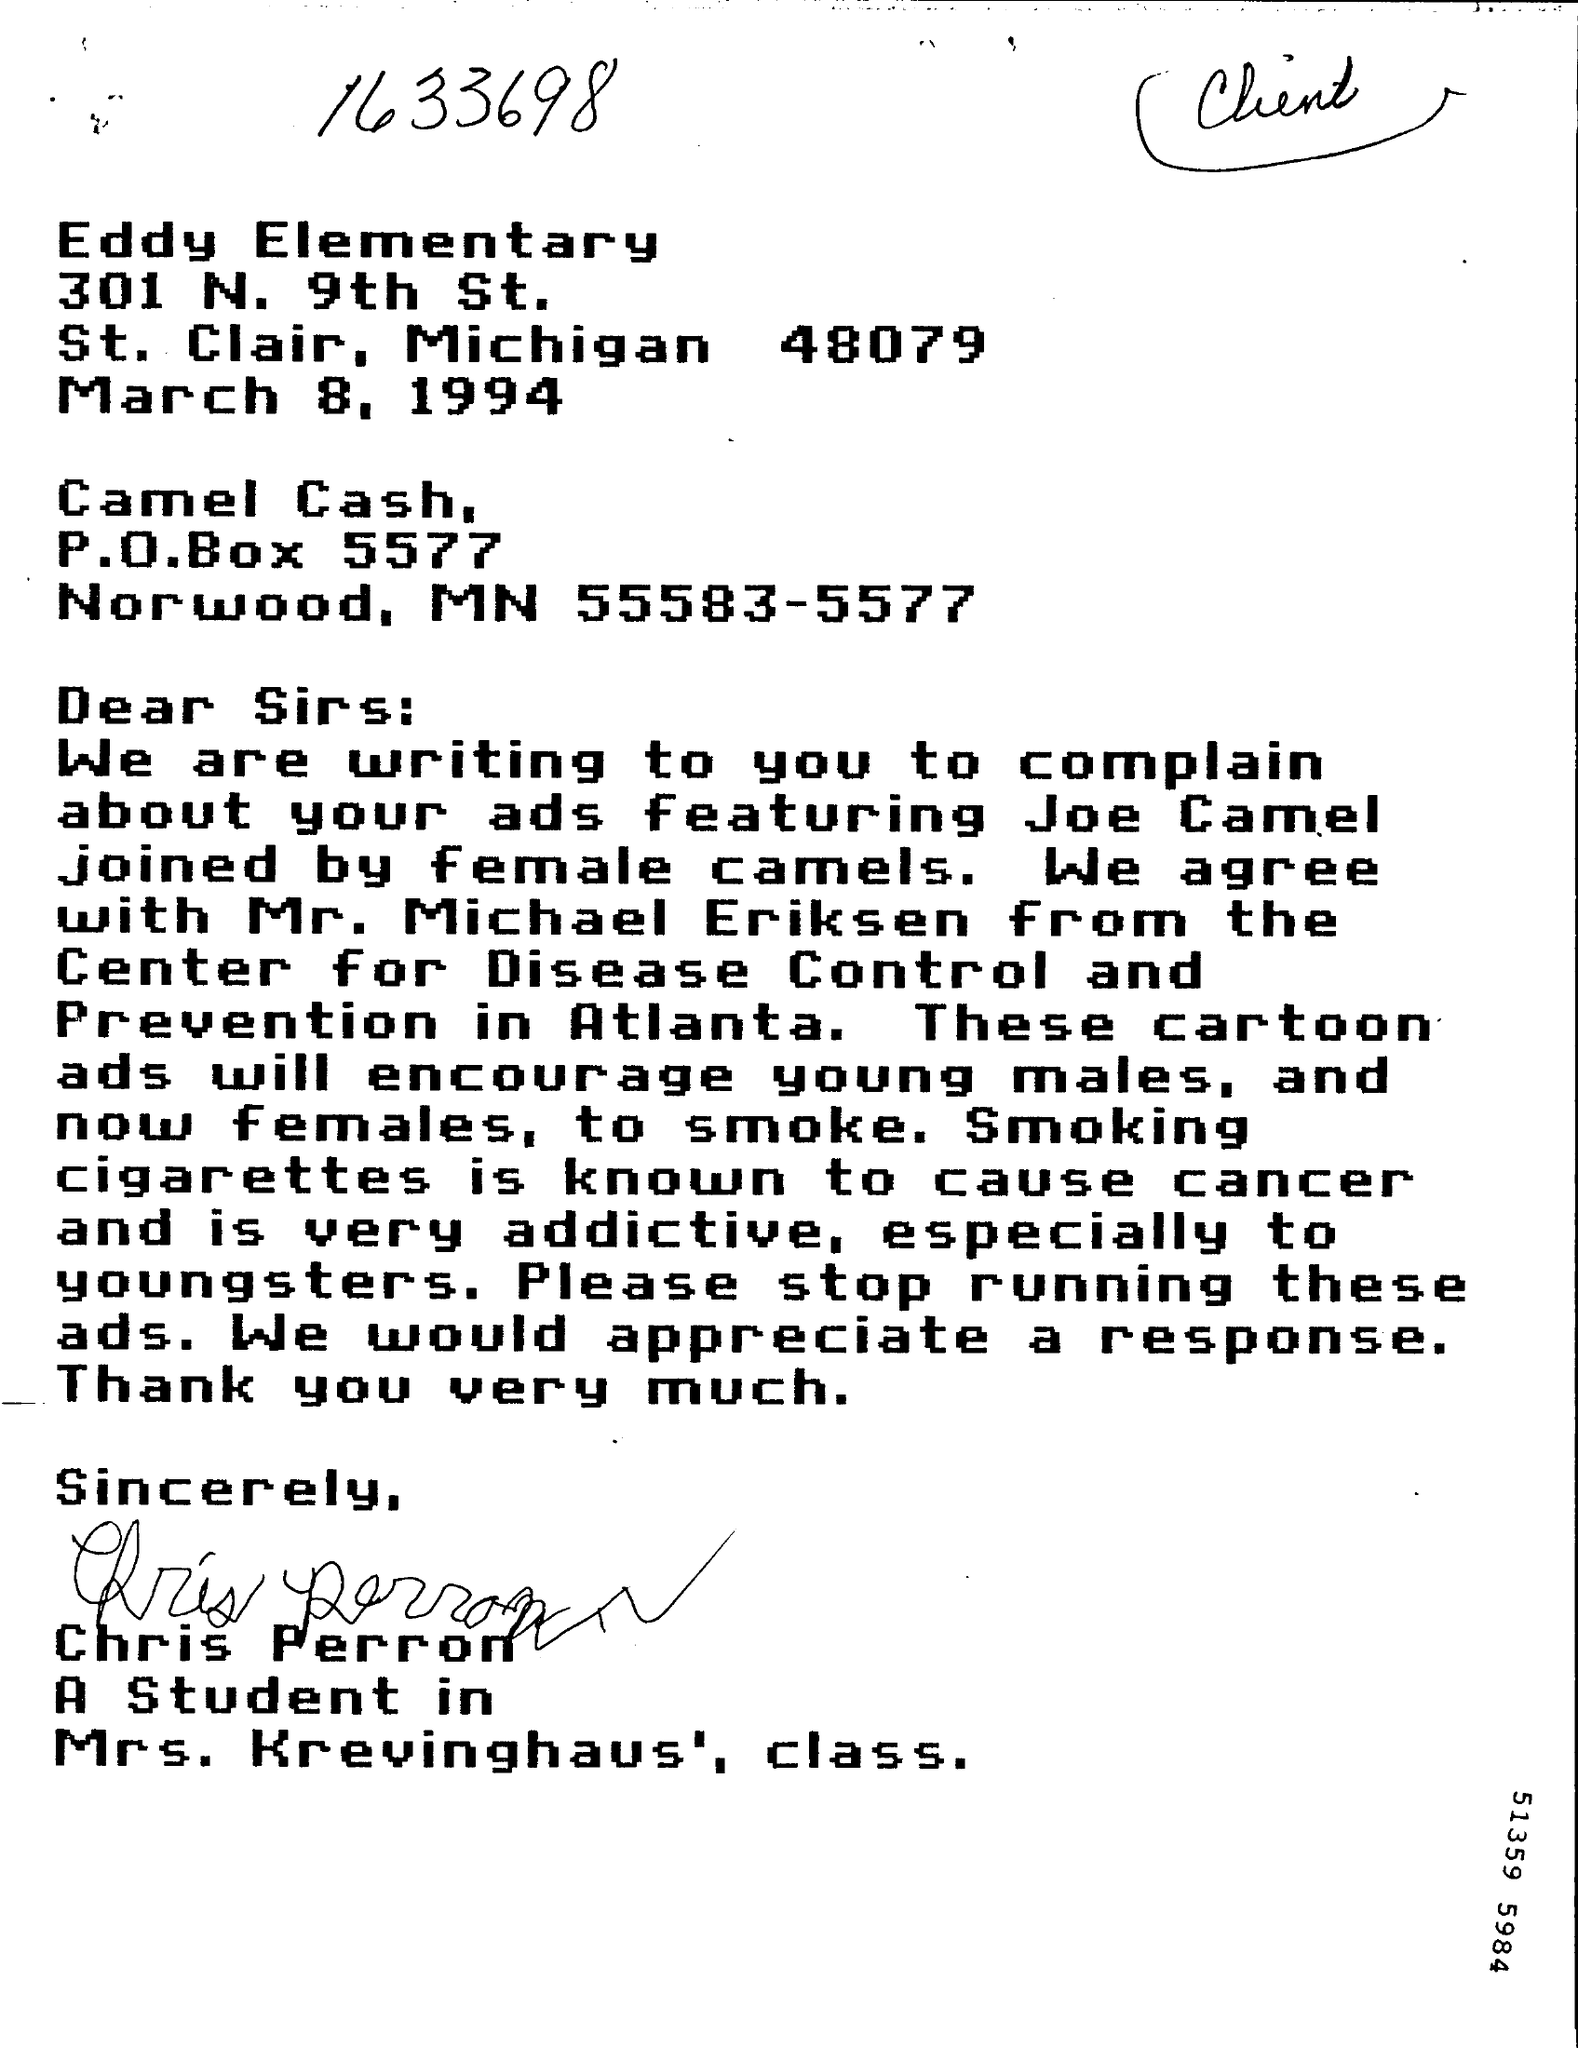What is the P.O Box Number ?
Provide a succinct answer. P.O.Box 5577. 